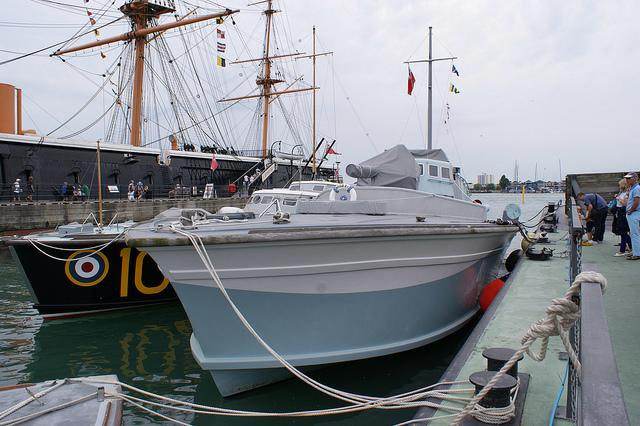What are the people ready to do?

Choices:
A) eat
B) run
C) deplane
D) board board 